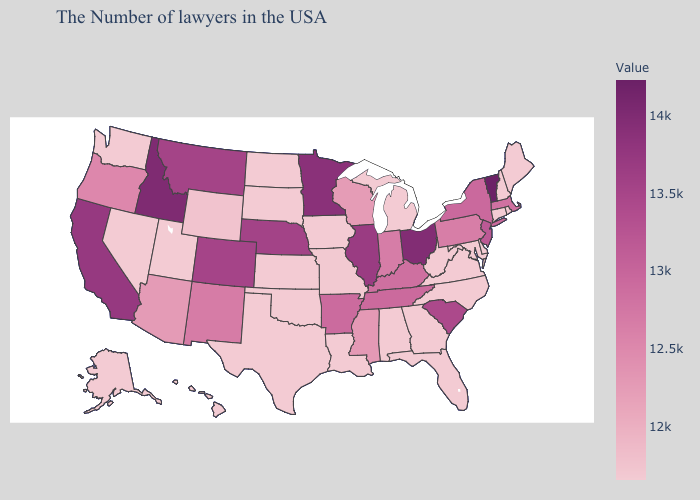Does Idaho have the highest value in the West?
Quick response, please. Yes. Which states have the lowest value in the USA?
Give a very brief answer. Maine, Rhode Island, New Hampshire, Connecticut, Delaware, Maryland, Virginia, North Carolina, West Virginia, Florida, Georgia, Michigan, Alabama, Louisiana, Iowa, Kansas, Oklahoma, Texas, South Dakota, North Dakota, Utah, Nevada, Washington, Alaska, Hawaii. Which states have the highest value in the USA?
Short answer required. Vermont. Which states have the lowest value in the USA?
Concise answer only. Maine, Rhode Island, New Hampshire, Connecticut, Delaware, Maryland, Virginia, North Carolina, West Virginia, Florida, Georgia, Michigan, Alabama, Louisiana, Iowa, Kansas, Oklahoma, Texas, South Dakota, North Dakota, Utah, Nevada, Washington, Alaska, Hawaii. Does Vermont have the highest value in the USA?
Write a very short answer. Yes. Does Kentucky have the lowest value in the South?
Write a very short answer. No. 